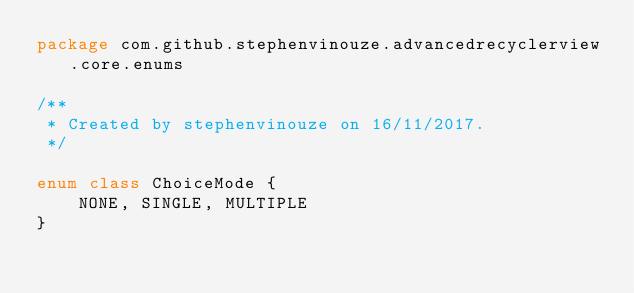Convert code to text. <code><loc_0><loc_0><loc_500><loc_500><_Kotlin_>package com.github.stephenvinouze.advancedrecyclerview.core.enums

/**
 * Created by stephenvinouze on 16/11/2017.
 */

enum class ChoiceMode {
    NONE, SINGLE, MULTIPLE
}</code> 